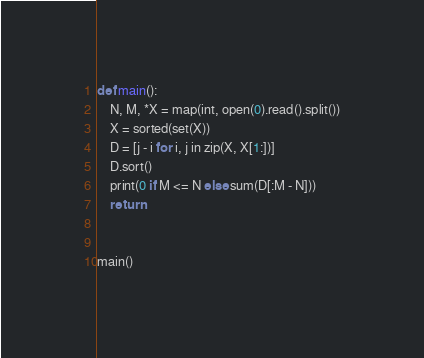<code> <loc_0><loc_0><loc_500><loc_500><_Python_>def main():
    N, M, *X = map(int, open(0).read().split())
    X = sorted(set(X))
    D = [j - i for i, j in zip(X, X[1:])]
    D.sort()
    print(0 if M <= N else sum(D[:M - N]))
    return


main()
</code> 